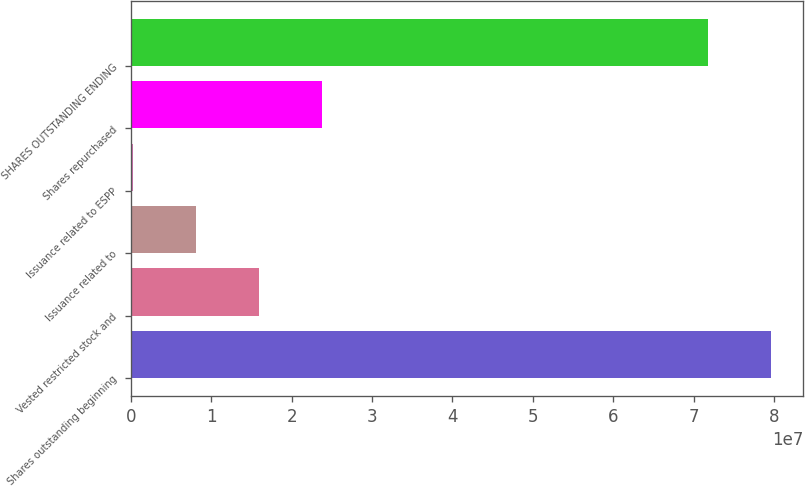<chart> <loc_0><loc_0><loc_500><loc_500><bar_chart><fcel>Shares outstanding beginning<fcel>Vested restricted stock and<fcel>Issuance related to<fcel>Issuance related to ESPP<fcel>Shares repurchased<fcel>SHARES OUTSTANDING ENDING<nl><fcel>7.96729e+07<fcel>1.59069e+07<fcel>8.06222e+06<fcel>217573<fcel>2.37515e+07<fcel>7.18282e+07<nl></chart> 